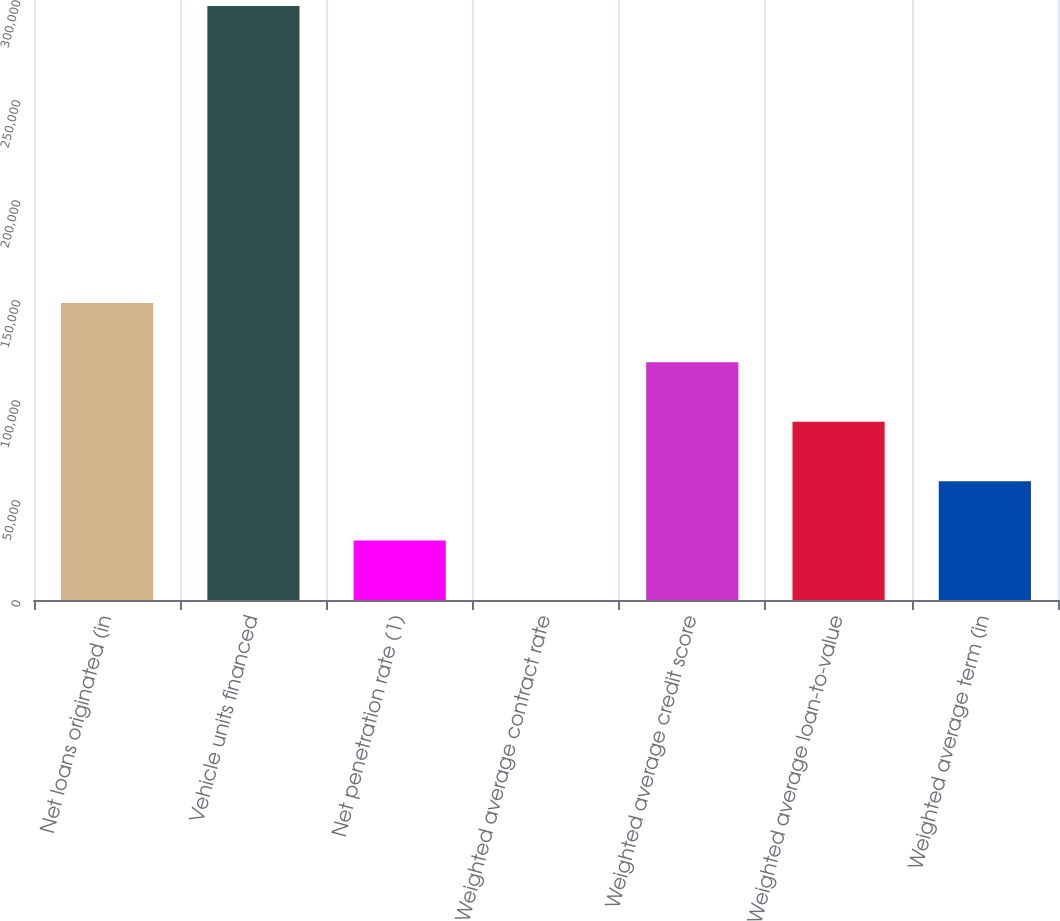Convert chart to OTSL. <chart><loc_0><loc_0><loc_500><loc_500><bar_chart><fcel>Net loans originated (in<fcel>Vehicle units financed<fcel>Net penetration rate (1)<fcel>Weighted average contract rate<fcel>Weighted average credit score<fcel>Weighted average loan-to-value<fcel>Weighted average term (in<nl><fcel>148525<fcel>297043<fcel>29711<fcel>7.4<fcel>118822<fcel>89118.1<fcel>59414.5<nl></chart> 